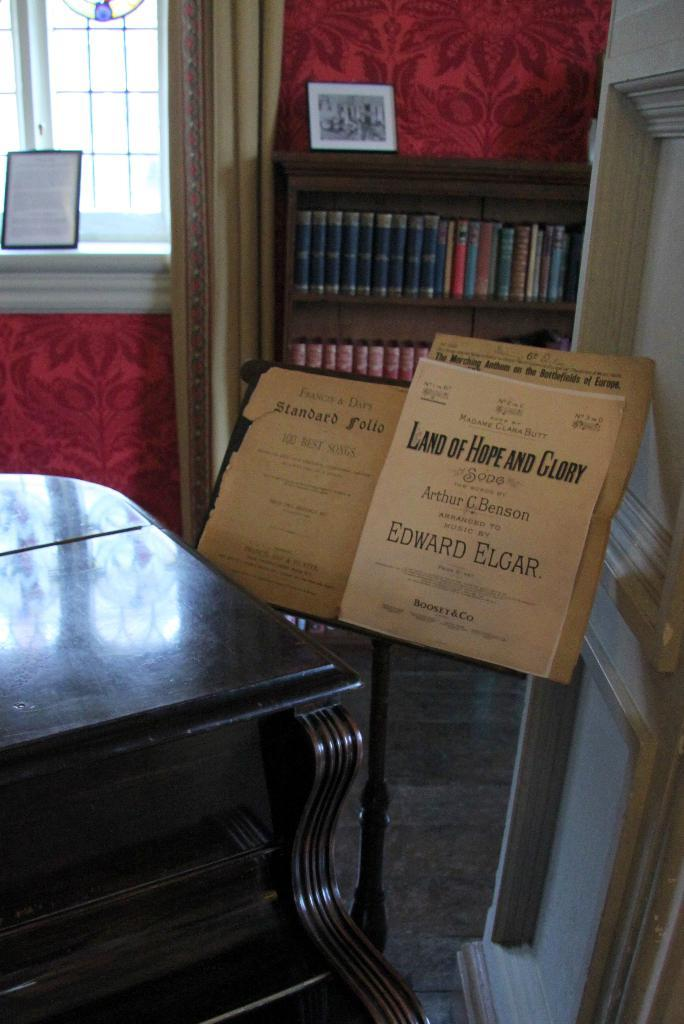<image>
Offer a succinct explanation of the picture presented. Brown box on a stand that says "Land of Hope and Glory". 